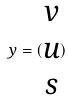<formula> <loc_0><loc_0><loc_500><loc_500>y = ( \begin{matrix} v \\ u \\ s \end{matrix} )</formula> 